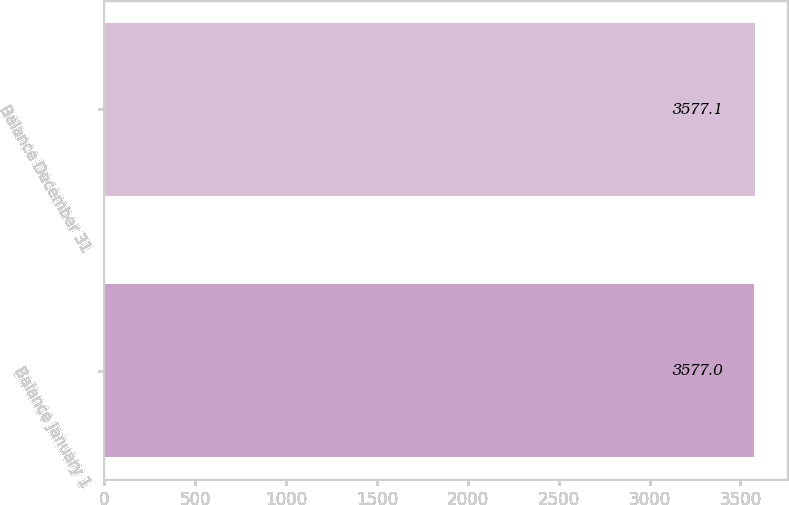<chart> <loc_0><loc_0><loc_500><loc_500><bar_chart><fcel>Balance January 1<fcel>Balance December 31<nl><fcel>3577<fcel>3577.1<nl></chart> 